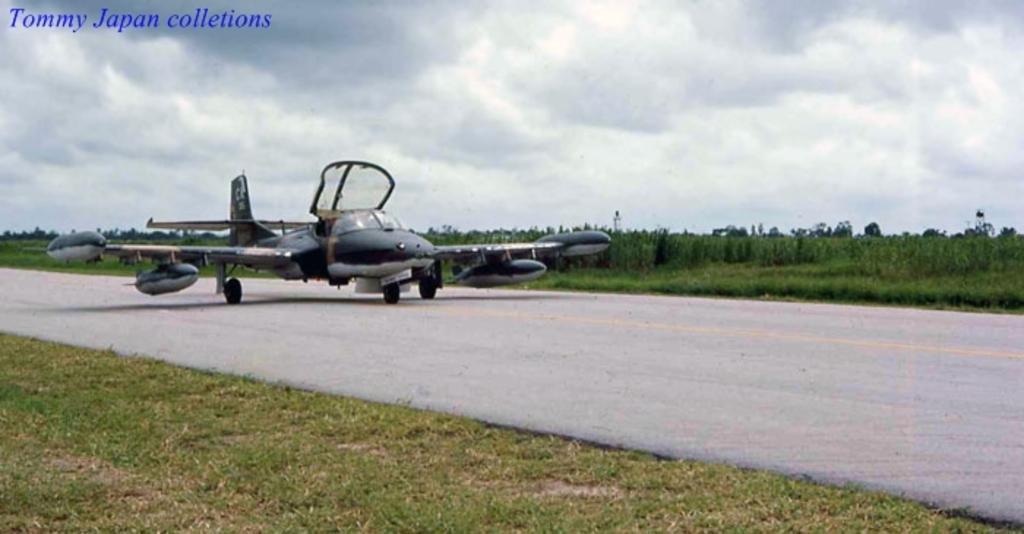In one or two sentences, can you explain what this image depicts? In this picture I can see a jet plane and trees and I can see text at the top left corner and a cloudy sky and I can see grass on the ground. 